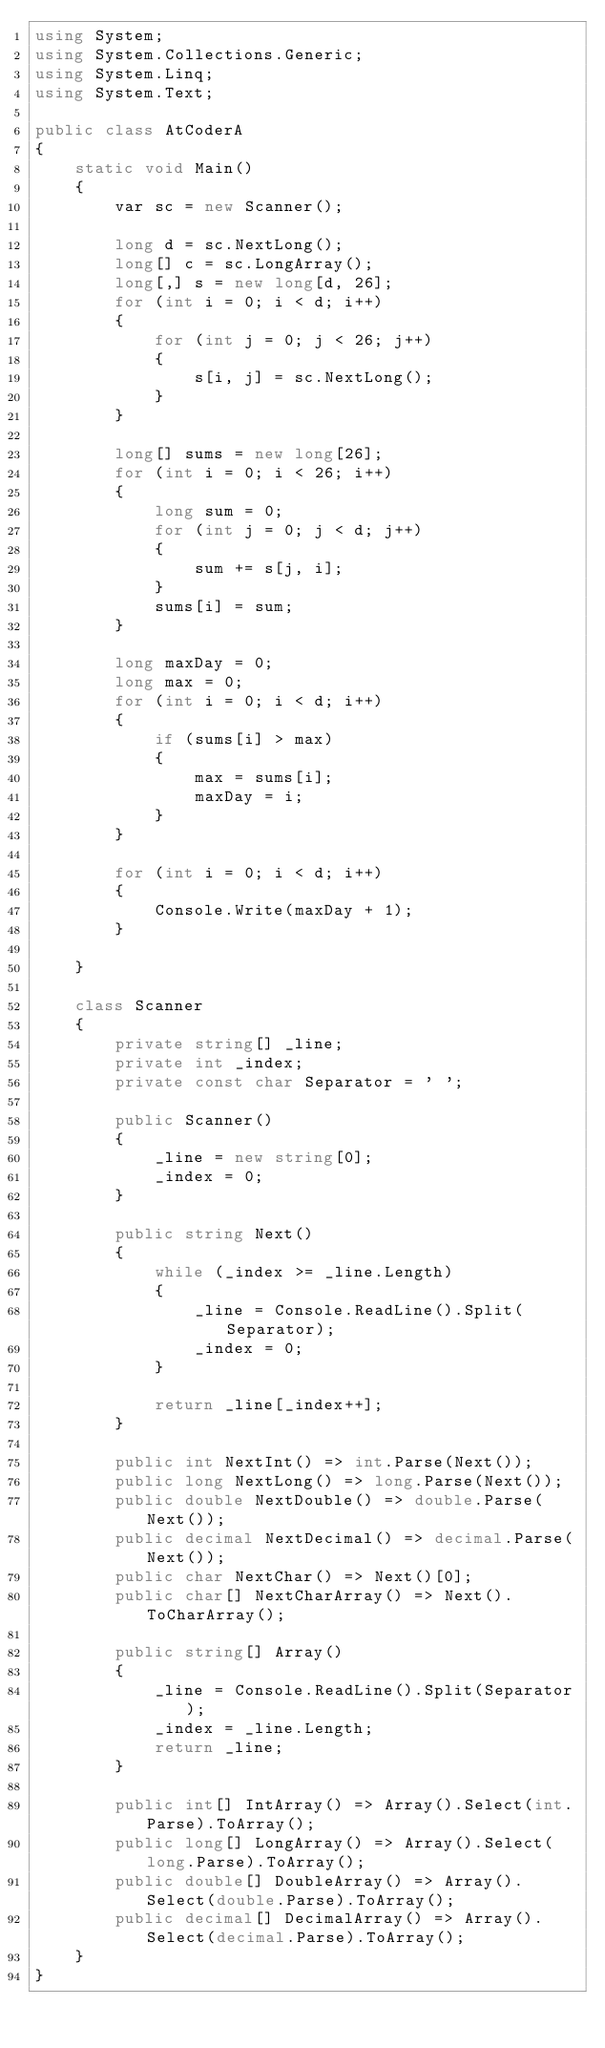<code> <loc_0><loc_0><loc_500><loc_500><_C#_>using System;
using System.Collections.Generic;
using System.Linq;
using System.Text;

public class AtCoderA
{
    static void Main()
    {
        var sc = new Scanner();

        long d = sc.NextLong();
        long[] c = sc.LongArray();
        long[,] s = new long[d, 26];
        for (int i = 0; i < d; i++)
        {
            for (int j = 0; j < 26; j++)
            {
                s[i, j] = sc.NextLong();
            }
        }

        long[] sums = new long[26];
        for (int i = 0; i < 26; i++)
        {
            long sum = 0;
            for (int j = 0; j < d; j++)
            {
                sum += s[j, i];
            }
            sums[i] = sum;
        }

        long maxDay = 0;
        long max = 0;
        for (int i = 0; i < d; i++)
        {
            if (sums[i] > max)
            {
                max = sums[i];
                maxDay = i;
            }
        }

        for (int i = 0; i < d; i++)
        {
            Console.Write(maxDay + 1);
        }

    }

    class Scanner
    {
        private string[] _line;
        private int _index;
        private const char Separator = ' ';

        public Scanner()
        {
            _line = new string[0];
            _index = 0;
        }

        public string Next()
        {
            while (_index >= _line.Length)
            {
                _line = Console.ReadLine().Split(Separator);
                _index = 0;
            }

            return _line[_index++];
        }

        public int NextInt() => int.Parse(Next());
        public long NextLong() => long.Parse(Next());
        public double NextDouble() => double.Parse(Next());
        public decimal NextDecimal() => decimal.Parse(Next());
        public char NextChar() => Next()[0];
        public char[] NextCharArray() => Next().ToCharArray();

        public string[] Array()
        {
            _line = Console.ReadLine().Split(Separator);
            _index = _line.Length;
            return _line;
        }

        public int[] IntArray() => Array().Select(int.Parse).ToArray();
        public long[] LongArray() => Array().Select(long.Parse).ToArray();
        public double[] DoubleArray() => Array().Select(double.Parse).ToArray();
        public decimal[] DecimalArray() => Array().Select(decimal.Parse).ToArray();
    }
}
</code> 